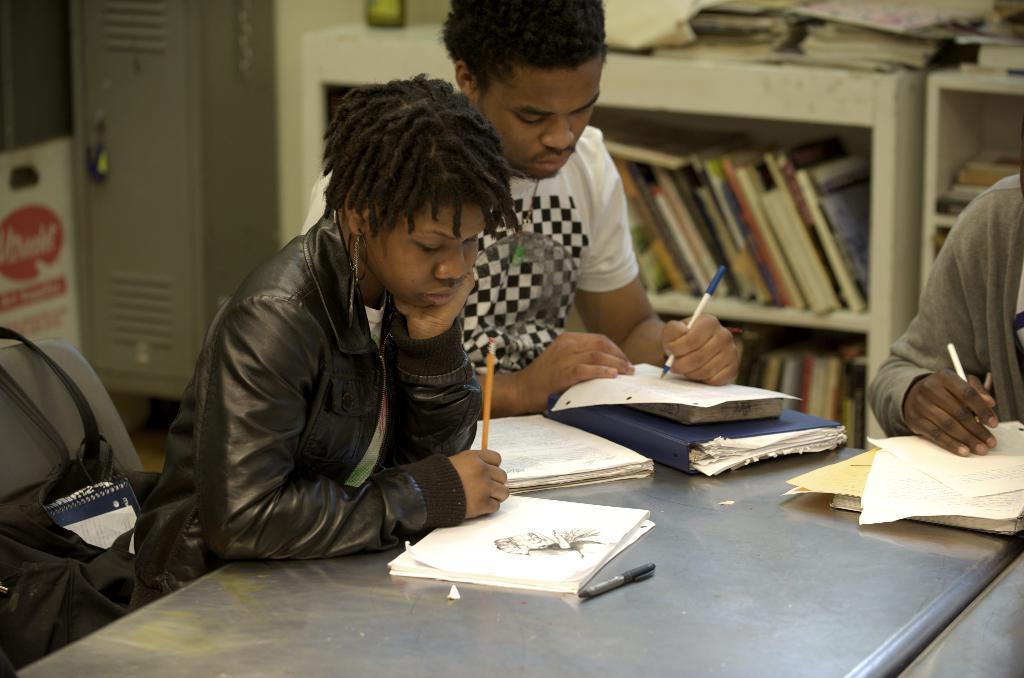Can you describe this image briefly? In this picture we can see two persons are sitting on the chair, and holding a pen in hand and writing on it, and here is the table , and at back here is the book rack. 